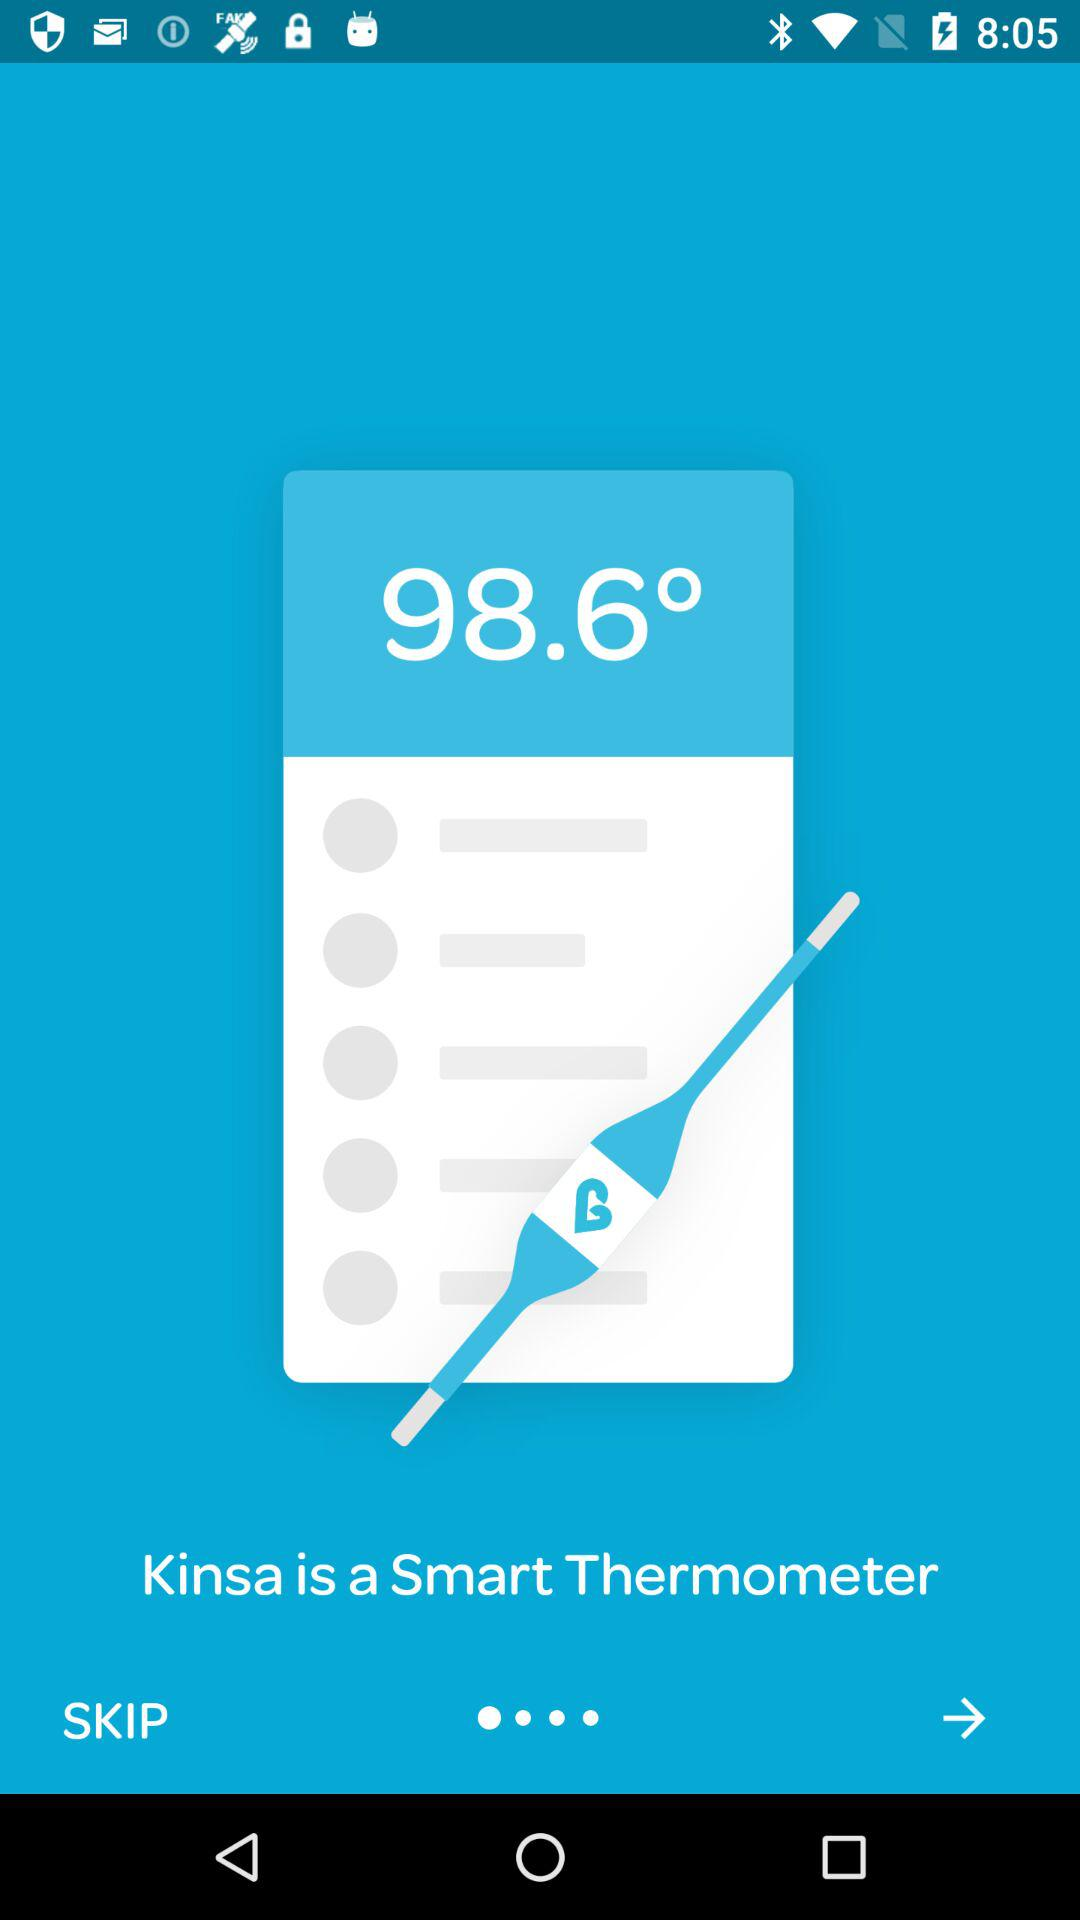What is the temperature? The temperature is 98.6°. 